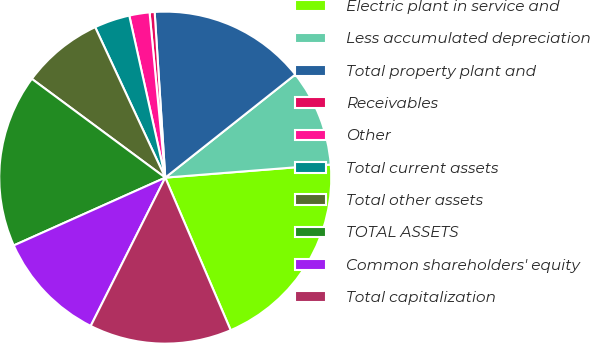<chart> <loc_0><loc_0><loc_500><loc_500><pie_chart><fcel>Electric plant in service and<fcel>Less accumulated depreciation<fcel>Total property plant and<fcel>Receivables<fcel>Other<fcel>Total current assets<fcel>Total other assets<fcel>TOTAL ASSETS<fcel>Common shareholders' equity<fcel>Total capitalization<nl><fcel>19.81%<fcel>9.41%<fcel>15.35%<fcel>0.49%<fcel>1.97%<fcel>3.46%<fcel>7.92%<fcel>16.84%<fcel>10.89%<fcel>13.86%<nl></chart> 